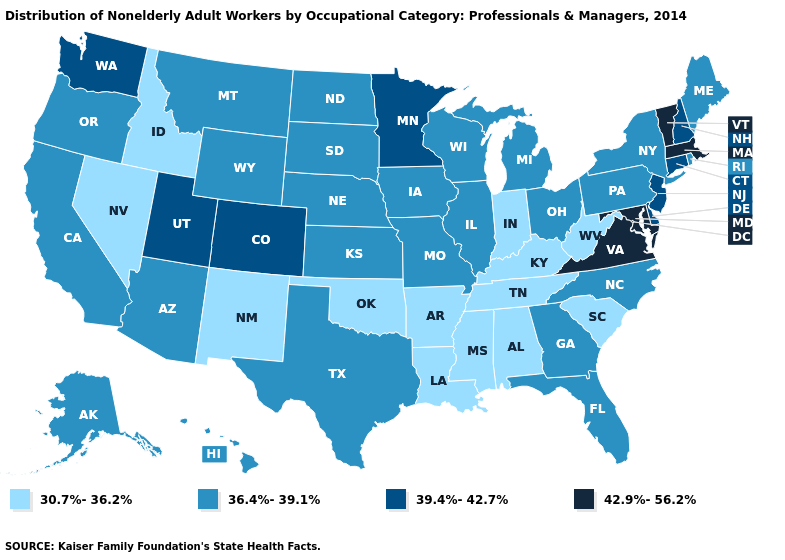What is the value of Wyoming?
Be succinct. 36.4%-39.1%. What is the value of California?
Short answer required. 36.4%-39.1%. Name the states that have a value in the range 42.9%-56.2%?
Be succinct. Maryland, Massachusetts, Vermont, Virginia. Name the states that have a value in the range 30.7%-36.2%?
Keep it brief. Alabama, Arkansas, Idaho, Indiana, Kentucky, Louisiana, Mississippi, Nevada, New Mexico, Oklahoma, South Carolina, Tennessee, West Virginia. Name the states that have a value in the range 39.4%-42.7%?
Keep it brief. Colorado, Connecticut, Delaware, Minnesota, New Hampshire, New Jersey, Utah, Washington. Name the states that have a value in the range 30.7%-36.2%?
Quick response, please. Alabama, Arkansas, Idaho, Indiana, Kentucky, Louisiana, Mississippi, Nevada, New Mexico, Oklahoma, South Carolina, Tennessee, West Virginia. What is the value of Arizona?
Answer briefly. 36.4%-39.1%. What is the value of Iowa?
Write a very short answer. 36.4%-39.1%. What is the value of Arkansas?
Keep it brief. 30.7%-36.2%. Name the states that have a value in the range 39.4%-42.7%?
Short answer required. Colorado, Connecticut, Delaware, Minnesota, New Hampshire, New Jersey, Utah, Washington. Name the states that have a value in the range 42.9%-56.2%?
Answer briefly. Maryland, Massachusetts, Vermont, Virginia. Does Texas have the lowest value in the South?
Write a very short answer. No. Among the states that border Maryland , does West Virginia have the lowest value?
Write a very short answer. Yes. What is the lowest value in the West?
Keep it brief. 30.7%-36.2%. Name the states that have a value in the range 39.4%-42.7%?
Short answer required. Colorado, Connecticut, Delaware, Minnesota, New Hampshire, New Jersey, Utah, Washington. 